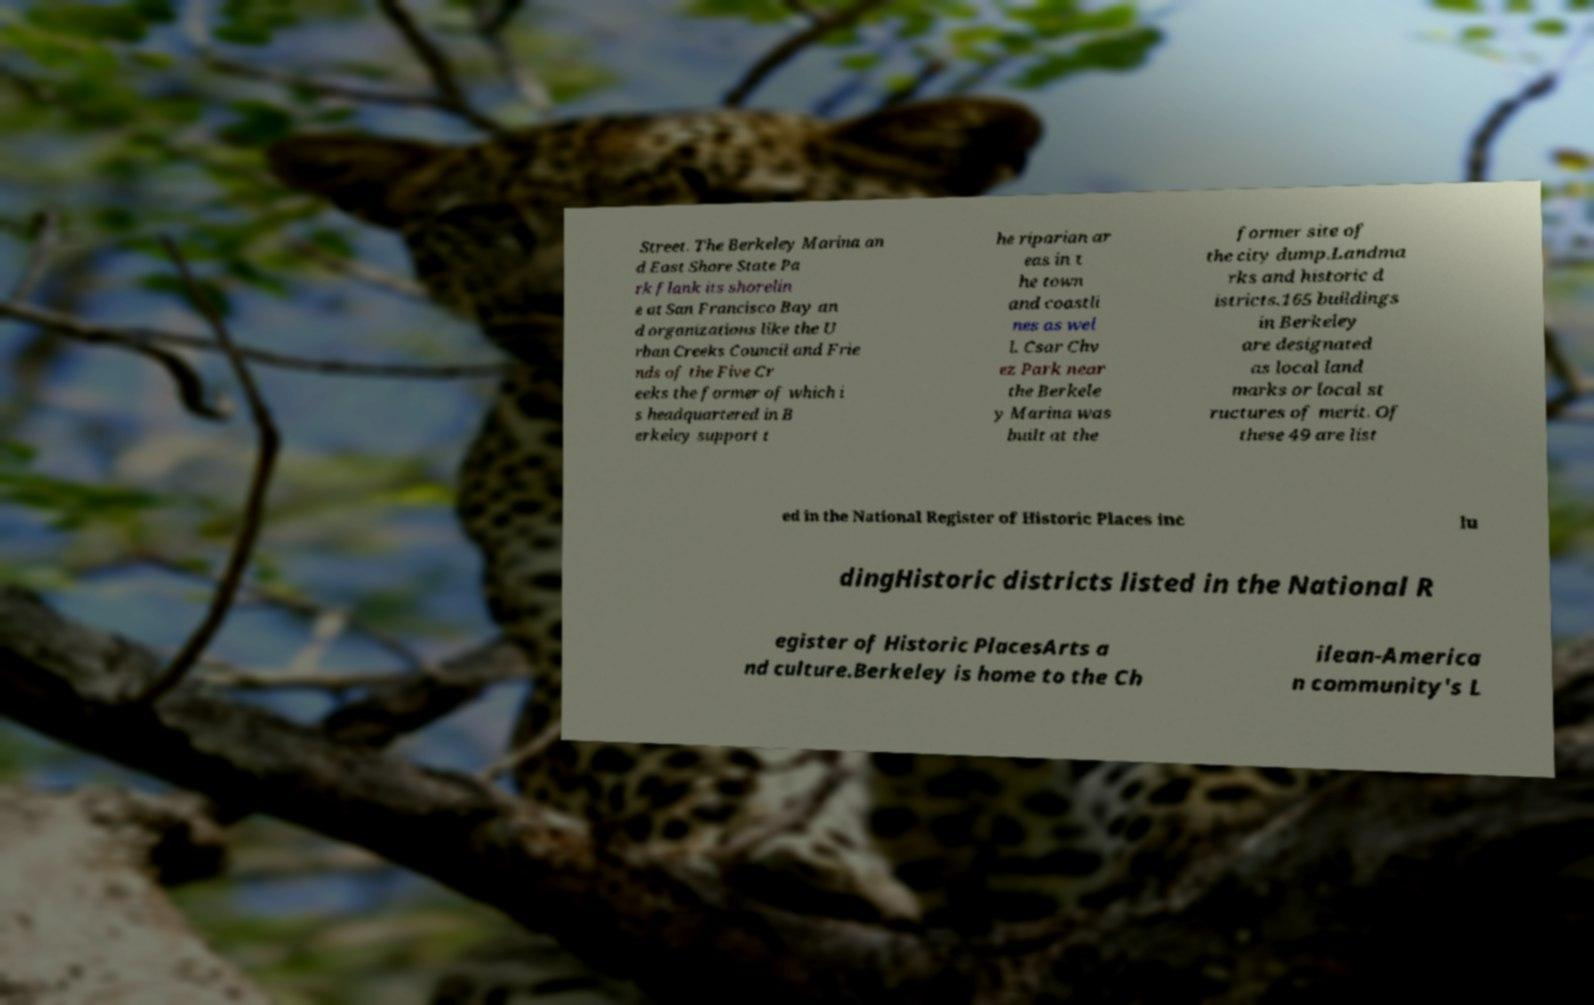There's text embedded in this image that I need extracted. Can you transcribe it verbatim? Street. The Berkeley Marina an d East Shore State Pa rk flank its shorelin e at San Francisco Bay an d organizations like the U rban Creeks Council and Frie nds of the Five Cr eeks the former of which i s headquartered in B erkeley support t he riparian ar eas in t he town and coastli nes as wel l. Csar Chv ez Park near the Berkele y Marina was built at the former site of the city dump.Landma rks and historic d istricts.165 buildings in Berkeley are designated as local land marks or local st ructures of merit. Of these 49 are list ed in the National Register of Historic Places inc lu dingHistoric districts listed in the National R egister of Historic PlacesArts a nd culture.Berkeley is home to the Ch ilean-America n community's L 